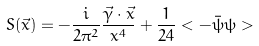<formula> <loc_0><loc_0><loc_500><loc_500>S ( \vec { x } ) = - \frac { i } { 2 \pi ^ { 2 } } \frac { \vec { \gamma } \cdot \vec { x } } { x ^ { 4 } } + \frac { 1 } { 2 4 } < - \bar { \psi } \psi ></formula> 